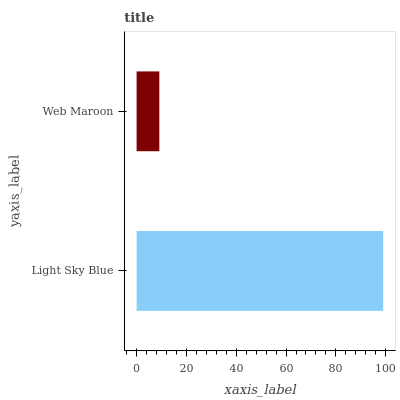Is Web Maroon the minimum?
Answer yes or no. Yes. Is Light Sky Blue the maximum?
Answer yes or no. Yes. Is Web Maroon the maximum?
Answer yes or no. No. Is Light Sky Blue greater than Web Maroon?
Answer yes or no. Yes. Is Web Maroon less than Light Sky Blue?
Answer yes or no. Yes. Is Web Maroon greater than Light Sky Blue?
Answer yes or no. No. Is Light Sky Blue less than Web Maroon?
Answer yes or no. No. Is Light Sky Blue the high median?
Answer yes or no. Yes. Is Web Maroon the low median?
Answer yes or no. Yes. Is Web Maroon the high median?
Answer yes or no. No. Is Light Sky Blue the low median?
Answer yes or no. No. 